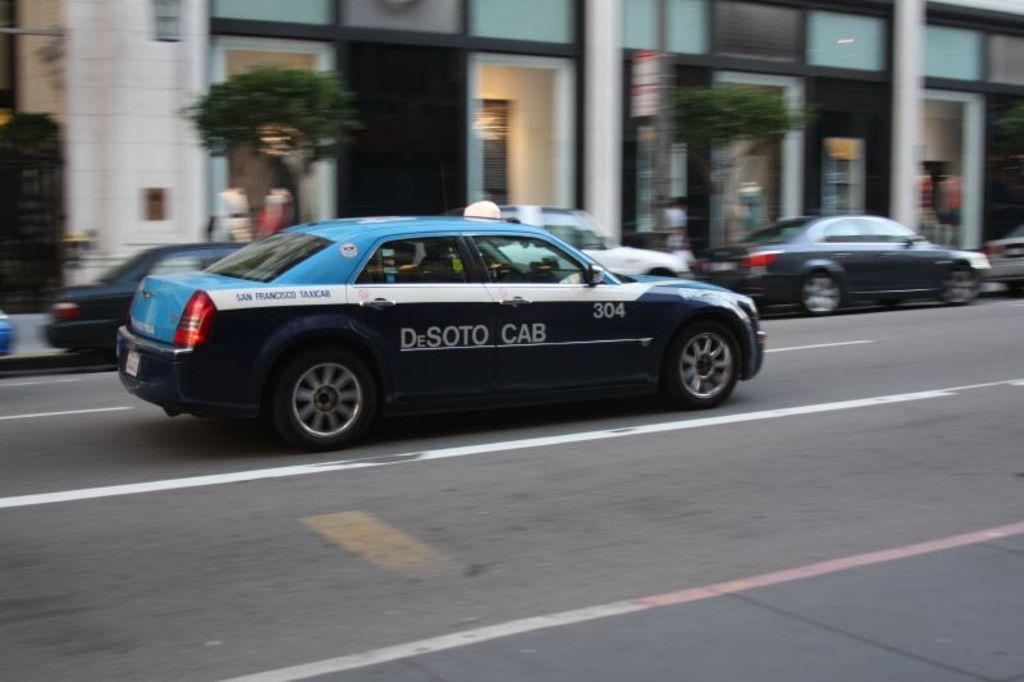Can you describe this image briefly? This picture shows few cars parked and a car moving on the road and we see buildings and trees 